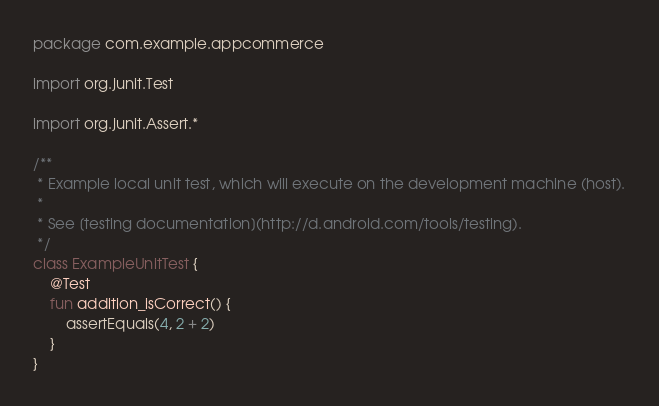Convert code to text. <code><loc_0><loc_0><loc_500><loc_500><_Kotlin_>package com.example.appcommerce

import org.junit.Test

import org.junit.Assert.*

/**
 * Example local unit test, which will execute on the development machine (host).
 *
 * See [testing documentation](http://d.android.com/tools/testing).
 */
class ExampleUnitTest {
    @Test
    fun addition_isCorrect() {
        assertEquals(4, 2 + 2)
    }
}</code> 